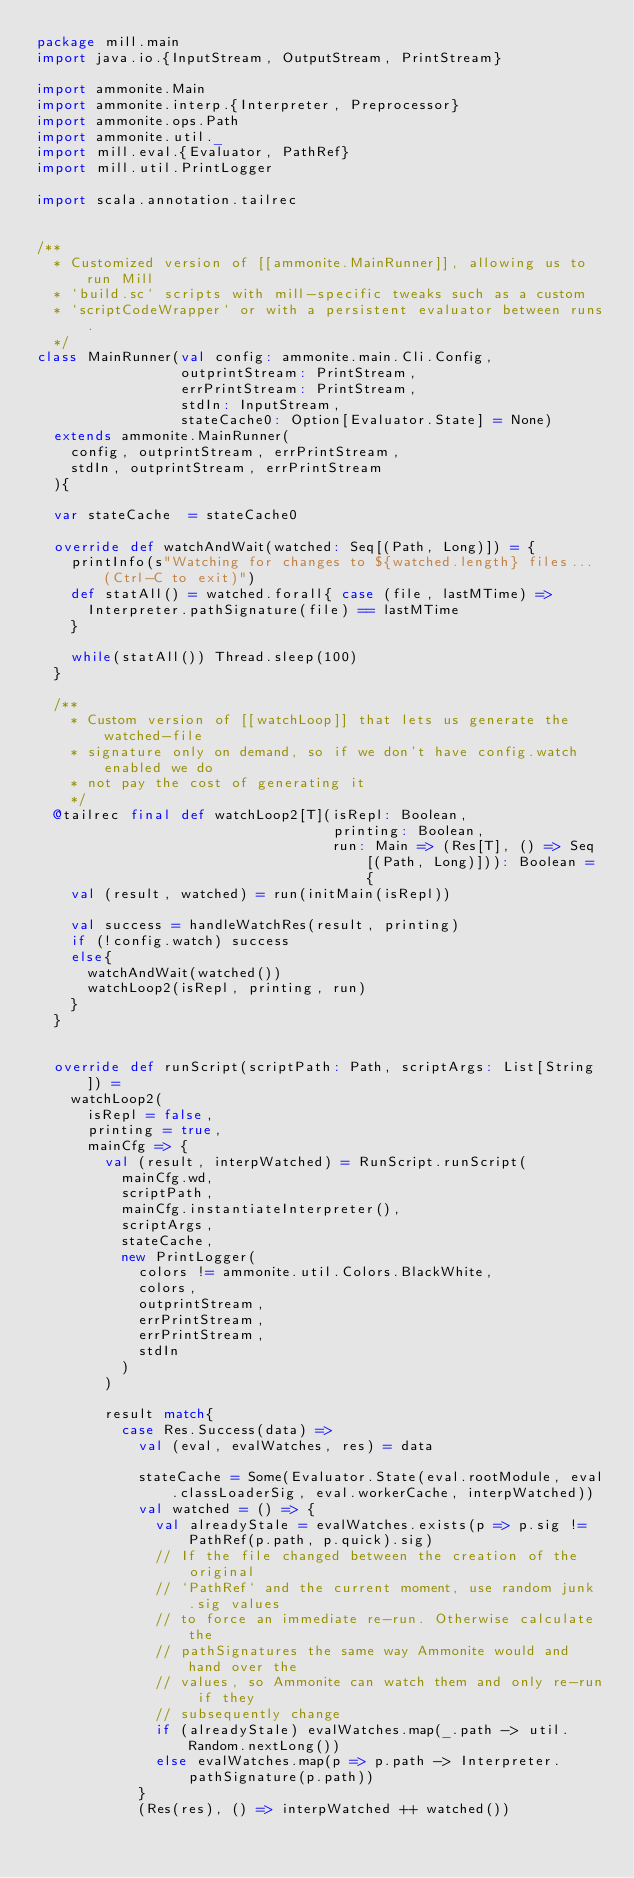<code> <loc_0><loc_0><loc_500><loc_500><_Scala_>package mill.main
import java.io.{InputStream, OutputStream, PrintStream}

import ammonite.Main
import ammonite.interp.{Interpreter, Preprocessor}
import ammonite.ops.Path
import ammonite.util._
import mill.eval.{Evaluator, PathRef}
import mill.util.PrintLogger

import scala.annotation.tailrec


/**
  * Customized version of [[ammonite.MainRunner]], allowing us to run Mill
  * `build.sc` scripts with mill-specific tweaks such as a custom
  * `scriptCodeWrapper` or with a persistent evaluator between runs.
  */
class MainRunner(val config: ammonite.main.Cli.Config,
                 outprintStream: PrintStream,
                 errPrintStream: PrintStream,
                 stdIn: InputStream,
                 stateCache0: Option[Evaluator.State] = None)
  extends ammonite.MainRunner(
    config, outprintStream, errPrintStream,
    stdIn, outprintStream, errPrintStream
  ){

  var stateCache  = stateCache0

  override def watchAndWait(watched: Seq[(Path, Long)]) = {
    printInfo(s"Watching for changes to ${watched.length} files... (Ctrl-C to exit)")
    def statAll() = watched.forall{ case (file, lastMTime) =>
      Interpreter.pathSignature(file) == lastMTime
    }

    while(statAll()) Thread.sleep(100)
  }

  /**
    * Custom version of [[watchLoop]] that lets us generate the watched-file
    * signature only on demand, so if we don't have config.watch enabled we do
    * not pay the cost of generating it
    */
  @tailrec final def watchLoop2[T](isRepl: Boolean,
                                   printing: Boolean,
                                   run: Main => (Res[T], () => Seq[(Path, Long)])): Boolean = {
    val (result, watched) = run(initMain(isRepl))

    val success = handleWatchRes(result, printing)
    if (!config.watch) success
    else{
      watchAndWait(watched())
      watchLoop2(isRepl, printing, run)
    }
  }


  override def runScript(scriptPath: Path, scriptArgs: List[String]) =
    watchLoop2(
      isRepl = false,
      printing = true,
      mainCfg => {
        val (result, interpWatched) = RunScript.runScript(
          mainCfg.wd,
          scriptPath,
          mainCfg.instantiateInterpreter(),
          scriptArgs,
          stateCache,
          new PrintLogger(
            colors != ammonite.util.Colors.BlackWhite,
            colors,
            outprintStream,
            errPrintStream,
            errPrintStream,
            stdIn
          )
        )

        result match{
          case Res.Success(data) =>
            val (eval, evalWatches, res) = data

            stateCache = Some(Evaluator.State(eval.rootModule, eval.classLoaderSig, eval.workerCache, interpWatched))
            val watched = () => {
              val alreadyStale = evalWatches.exists(p => p.sig != PathRef(p.path, p.quick).sig)
              // If the file changed between the creation of the original
              // `PathRef` and the current moment, use random junk .sig values
              // to force an immediate re-run. Otherwise calculate the
              // pathSignatures the same way Ammonite would and hand over the
              // values, so Ammonite can watch them and only re-run if they
              // subsequently change
              if (alreadyStale) evalWatches.map(_.path -> util.Random.nextLong())
              else evalWatches.map(p => p.path -> Interpreter.pathSignature(p.path))
            }
            (Res(res), () => interpWatched ++ watched())</code> 